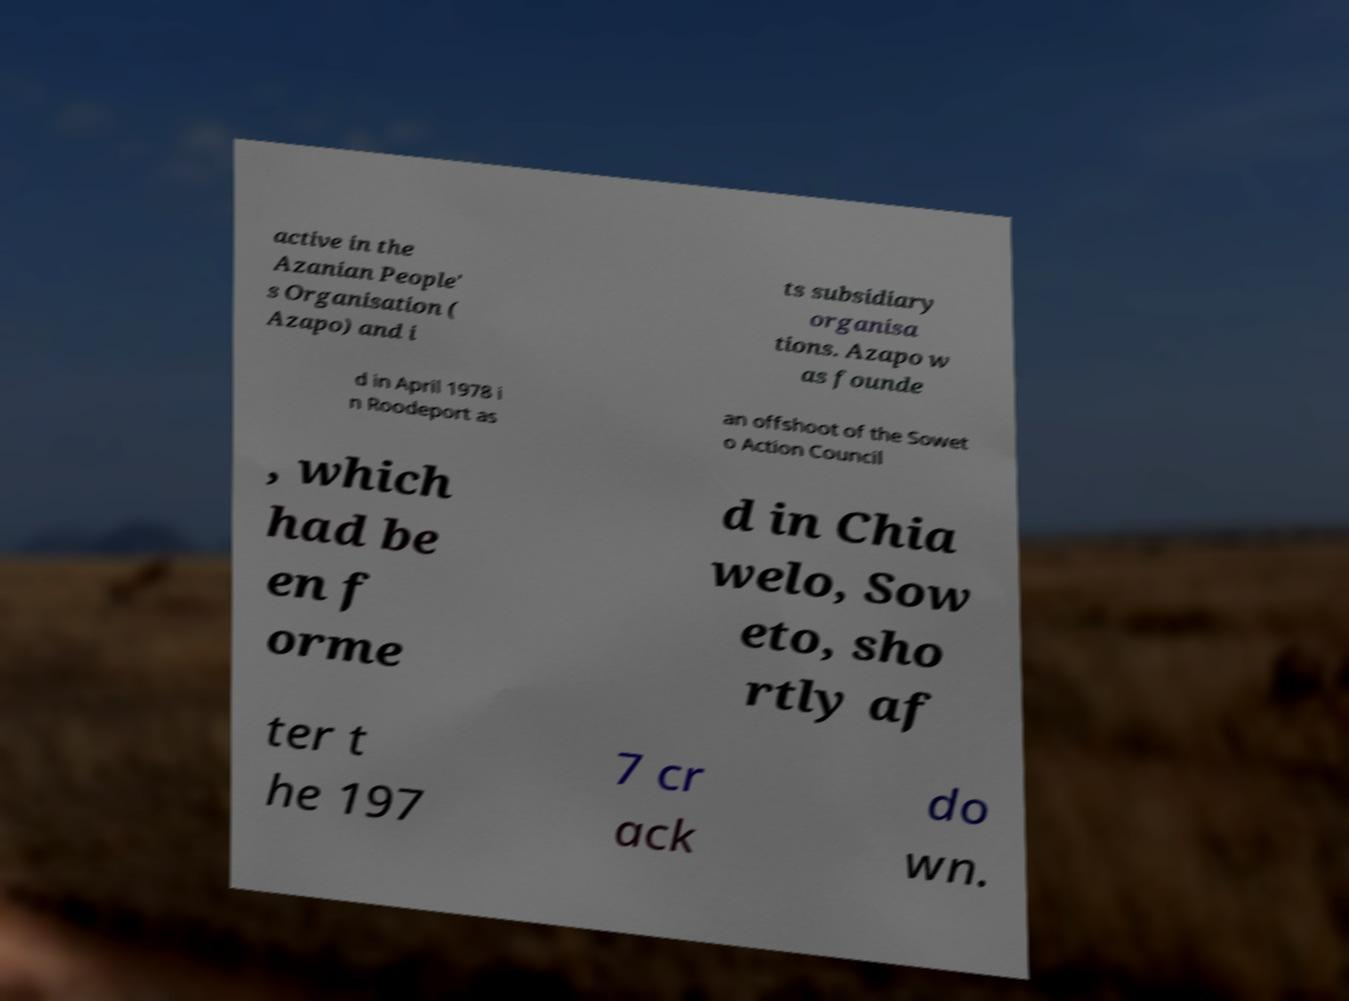What messages or text are displayed in this image? I need them in a readable, typed format. active in the Azanian People' s Organisation ( Azapo) and i ts subsidiary organisa tions. Azapo w as founde d in April 1978 i n Roodeport as an offshoot of the Sowet o Action Council , which had be en f orme d in Chia welo, Sow eto, sho rtly af ter t he 197 7 cr ack do wn. 